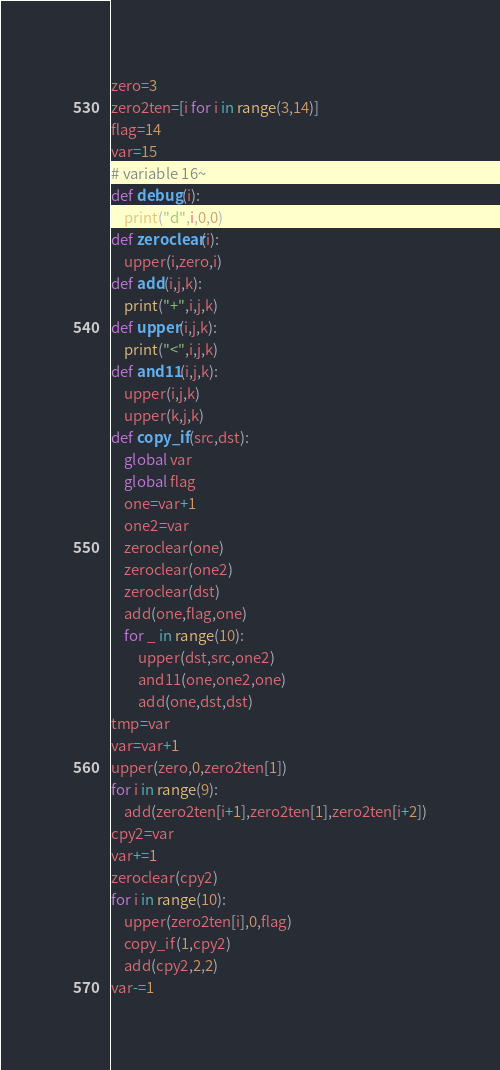Convert code to text. <code><loc_0><loc_0><loc_500><loc_500><_Python_>zero=3
zero2ten=[i for i in range(3,14)]
flag=14
var=15
# variable 16~
def debug(i):
    print("d",i,0,0)
def zeroclear(i):
    upper(i,zero,i)
def add(i,j,k):
    print("+",i,j,k)
def upper(i,j,k):
    print("<",i,j,k)
def and11(i,j,k):
    upper(i,j,k)
    upper(k,j,k)
def copy_if(src,dst):
    global var
    global flag
    one=var+1
    one2=var
    zeroclear(one)
    zeroclear(one2)
    zeroclear(dst)
    add(one,flag,one)
    for _ in range(10):
        upper(dst,src,one2)
        and11(one,one2,one)
        add(one,dst,dst)
tmp=var
var=var+1
upper(zero,0,zero2ten[1])
for i in range(9):
    add(zero2ten[i+1],zero2ten[1],zero2ten[i+2])
cpy2=var
var+=1
zeroclear(cpy2)
for i in range(10):
    upper(zero2ten[i],0,flag)
    copy_if(1,cpy2)
    add(cpy2,2,2)
var-=1</code> 